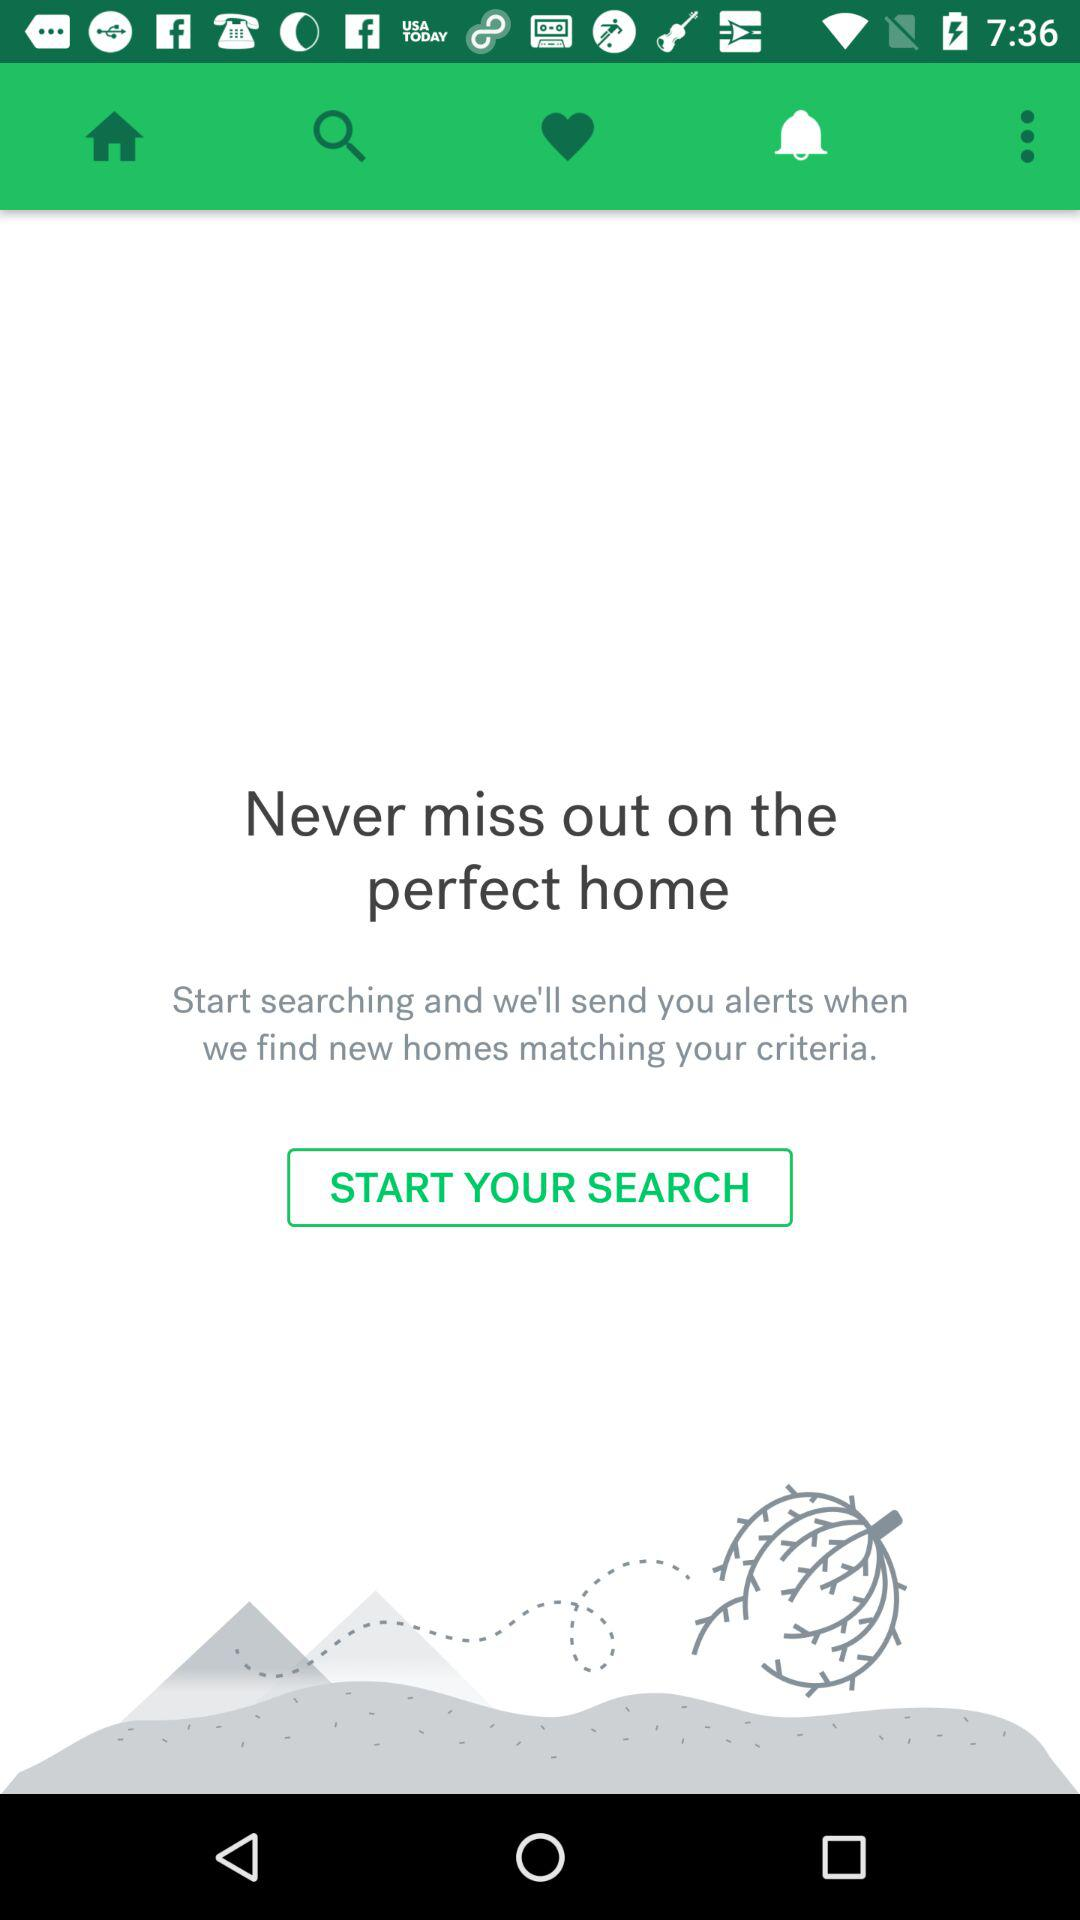Which tab am I on? You are on the notification tab. 